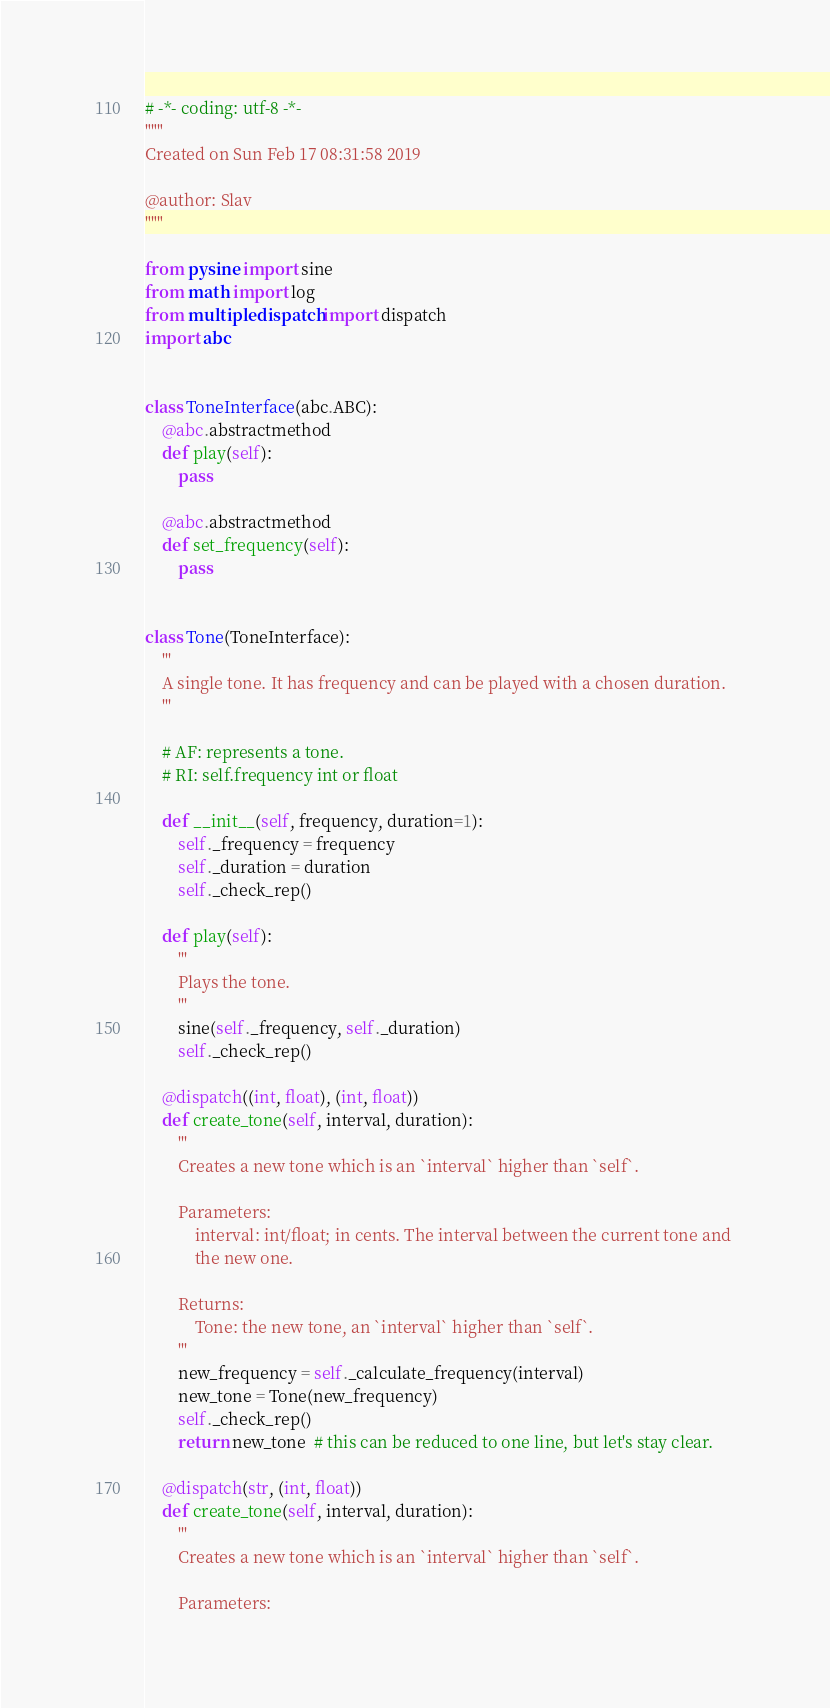<code> <loc_0><loc_0><loc_500><loc_500><_Python_># -*- coding: utf-8 -*-
"""
Created on Sun Feb 17 08:31:58 2019

@author: Slav
"""

from pysine import sine
from math import log
from multipledispatch import dispatch
import abc


class ToneInterface(abc.ABC):
    @abc.abstractmethod
    def play(self):
        pass

    @abc.abstractmethod
    def set_frequency(self):
        pass


class Tone(ToneInterface):
    '''
    A single tone. It has frequency and can be played with a chosen duration.
    '''

    # AF: represents a tone.
    # RI: self.frequency int or float

    def __init__(self, frequency, duration=1):
        self._frequency = frequency
        self._duration = duration
        self._check_rep()

    def play(self):
        '''
        Plays the tone.
        '''
        sine(self._frequency, self._duration)
        self._check_rep()

    @dispatch((int, float), (int, float))
    def create_tone(self, interval, duration):
        '''
        Creates a new tone which is an `interval` higher than `self`.
        
        Parameters:
            interval: int/float; in cents. The interval between the current tone and 
            the new one.
            
        Returns:
            Tone: the new tone, an `interval` higher than `self`.
        '''
        new_frequency = self._calculate_frequency(interval)
        new_tone = Tone(new_frequency)
        self._check_rep()
        return new_tone  # this can be reduced to one line, but let's stay clear.

    @dispatch(str, (int, float))
    def create_tone(self, interval, duration):
        '''
        Creates a new tone which is an `interval` higher than `self`.
        
        Parameters:</code> 